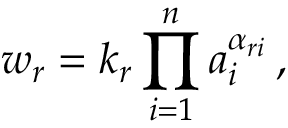<formula> <loc_0><loc_0><loc_500><loc_500>w _ { r } = k _ { r } \prod _ { i = 1 } ^ { n } a _ { i } ^ { \alpha _ { r i } } \, ,</formula> 